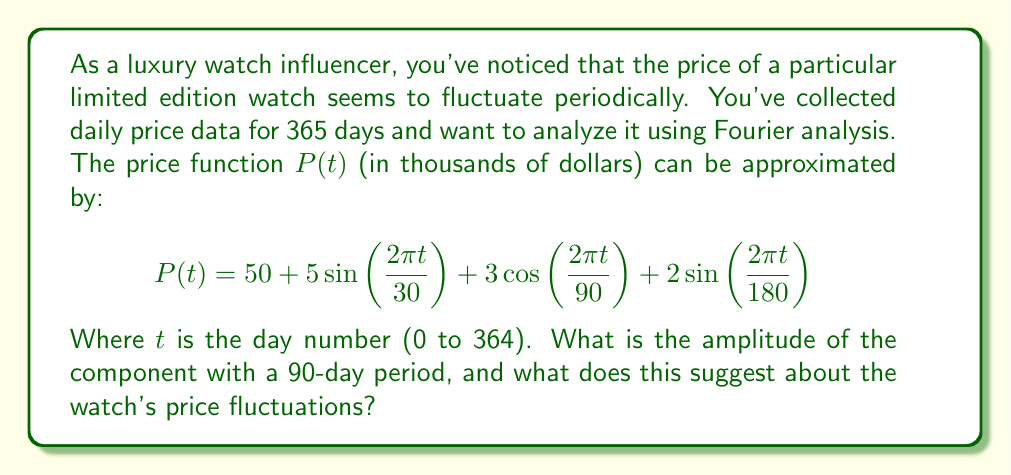Give your solution to this math problem. To solve this problem, we need to analyze the given price function using Fourier analysis principles:

1) The general form of a Fourier series is:
   $$f(t) = a_0 + \sum_{n=1}^{\infty} [a_n \cos(\frac{2\pi n t}{T}) + b_n \sin(\frac{2\pi n t}{T})]$$

2) In our case, we have:
   $$P(t) = 50 + 5\sin(\frac{2\pi t}{30}) + 3\cos(\frac{2\pi t}{90}) + 2\sin(\frac{2\pi t}{180})$$

3) Comparing this to the general form, we can identify:
   - $a_0 = 50$ (constant term)
   - A sine term with period 30 days
   - A cosine term with period 90 days
   - A sine term with period 180 days

4) The question asks about the component with a 90-day period, which is:
   $$3\cos(\frac{2\pi t}{90})$$

5) For a cosine term $a \cos(\omega t)$, the amplitude is simply $|a|$.

6) Therefore, the amplitude of the 90-day period component is 3.

This suggests that the watch's price fluctuates by $\pm 3,000 every 90 days, on top of other fluctuations. As a watch influencer, you might interpret this as a quarterly (roughly 3-month) cycle in the luxury watch market, possibly related to factors such as seasonal demand, quarterly financial reports of watch companies, or regular limited releases.
Answer: The amplitude of the component with a 90-day period is 3 (thousand dollars). 